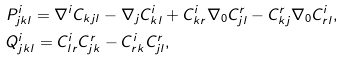Convert formula to latex. <formula><loc_0><loc_0><loc_500><loc_500>& P _ { j k l } ^ { i } = \nabla ^ { i } C _ { k j l } - \nabla _ { j } C ^ { i } _ { k l } + C ^ { i } _ { k r } \nabla _ { 0 } C ^ { r } _ { j l } - C ^ { r } _ { k j } \nabla _ { 0 } C ^ { i } _ { r l } , \\ & Q ^ { i } _ { j k l } = C ^ { i } _ { l r } C _ { j k } ^ { r } - C _ { r k } ^ { i } C _ { j l } ^ { r } ,</formula> 